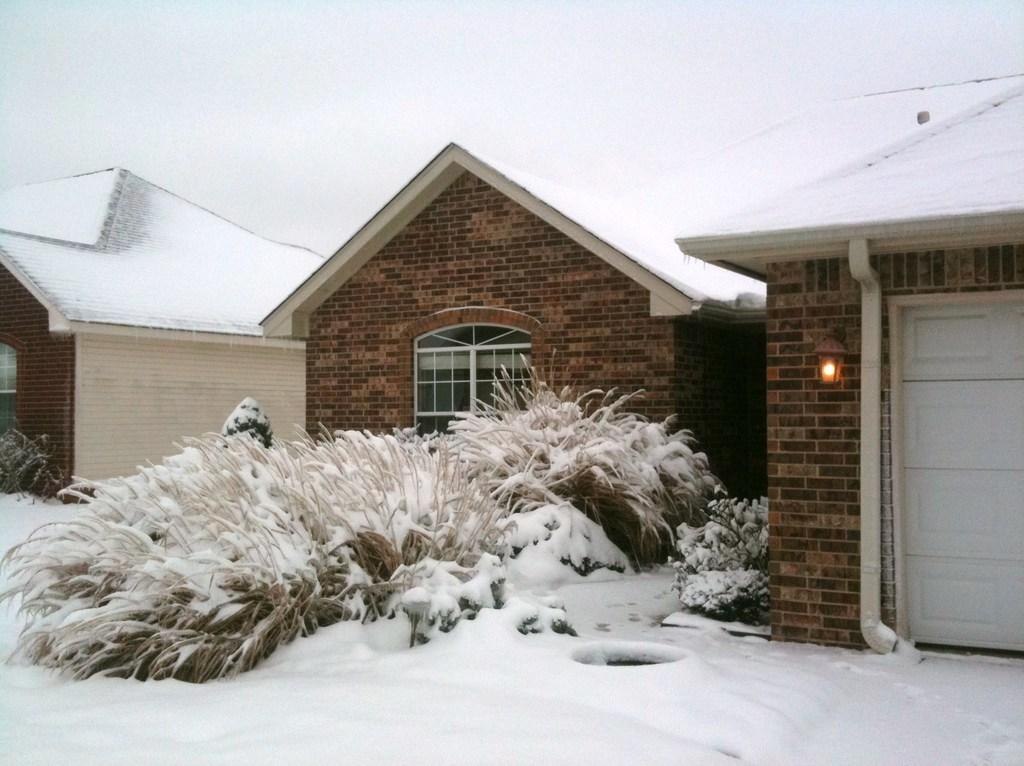What type of structures can be seen in the image? There are houses in the image. What other elements are present in the image besides the houses? There are plants in the image. How is the ground depicted in the image? The ground is covered with snow. Can you describe any additional features of the houses in the image? There is a light attached to the wall of one of the houses. How many birds are sitting on the tree in the image? There is no tree or birds present in the image. What type of bag is hanging on the wall of one of the houses? There is no bag visible in the image. 